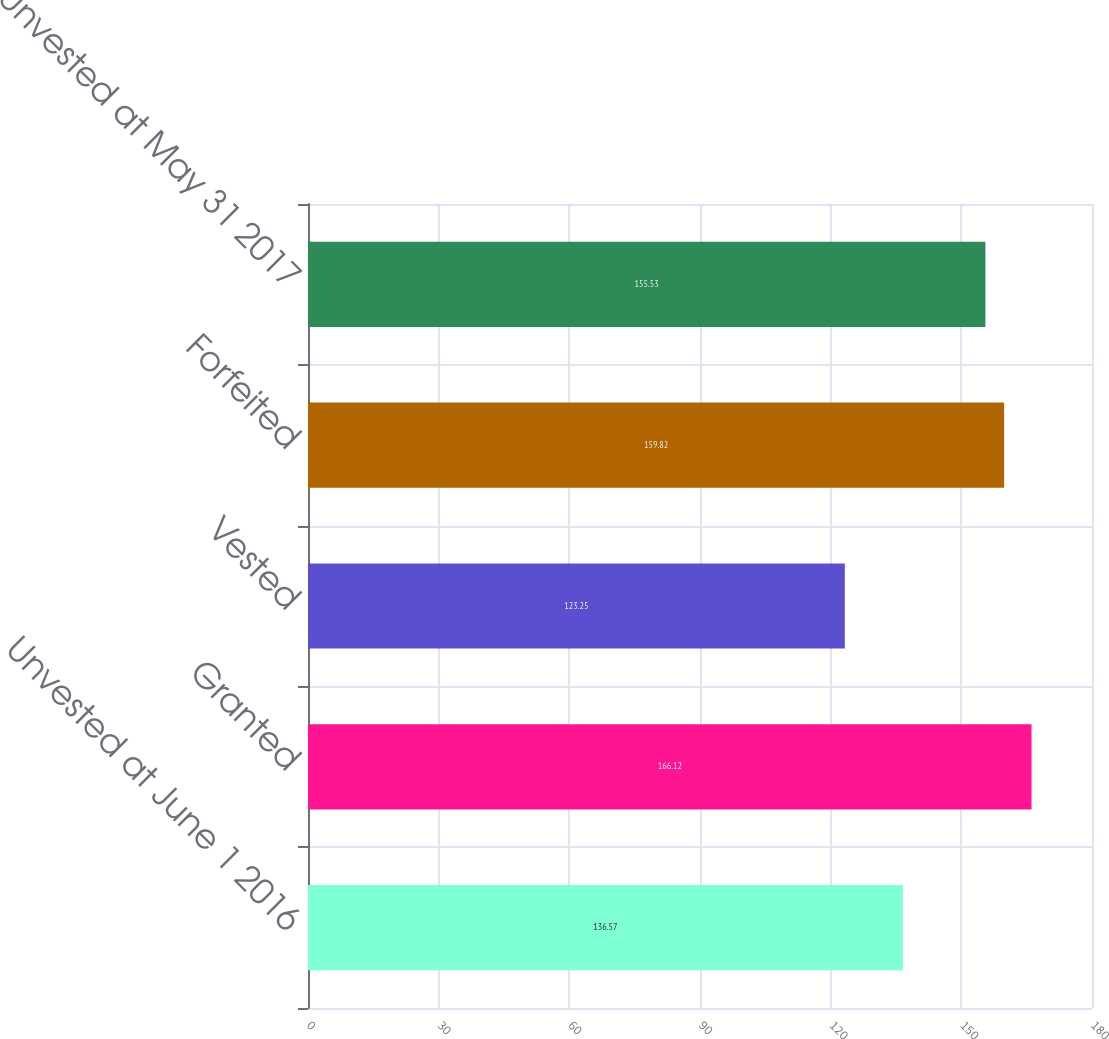Convert chart to OTSL. <chart><loc_0><loc_0><loc_500><loc_500><bar_chart><fcel>Unvested at June 1 2016<fcel>Granted<fcel>Vested<fcel>Forfeited<fcel>Unvested at May 31 2017<nl><fcel>136.57<fcel>166.12<fcel>123.25<fcel>159.82<fcel>155.53<nl></chart> 